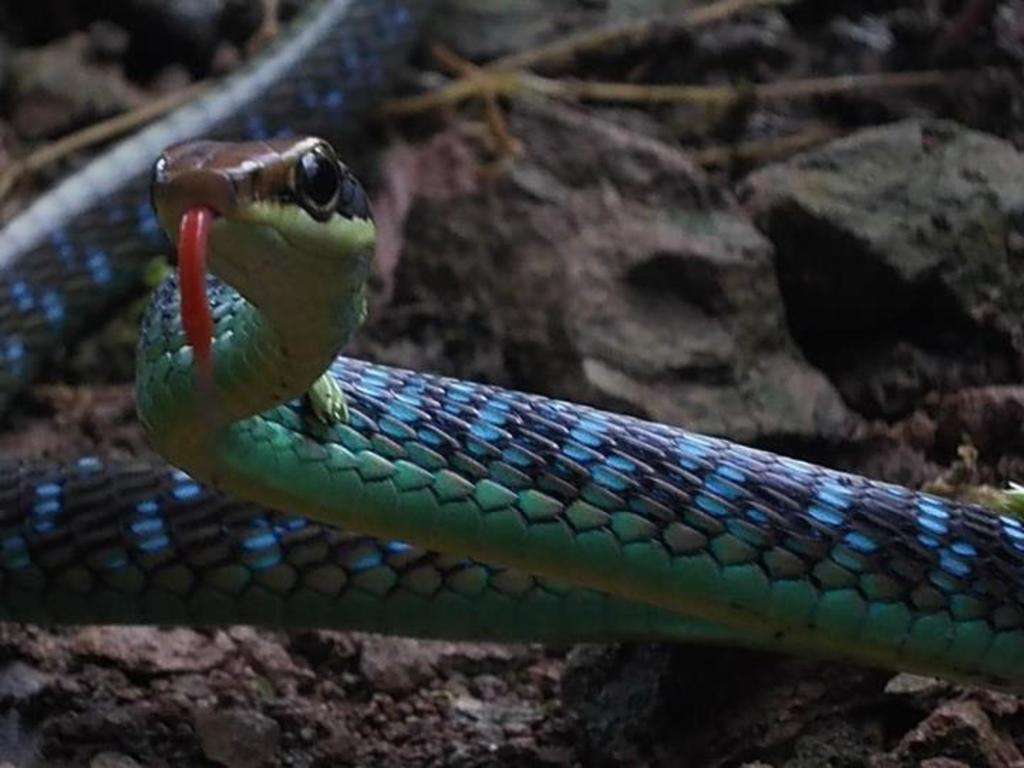What is the main subject in the center of the image? There is a snake in the center of the image. What can be seen in the background of the image? There are stones in the background of the image. What type of pickle is being used to comb the snake's veins in the image? There is no pickle, comb, or veins present in the image; it only features a snake and stones in the background. 